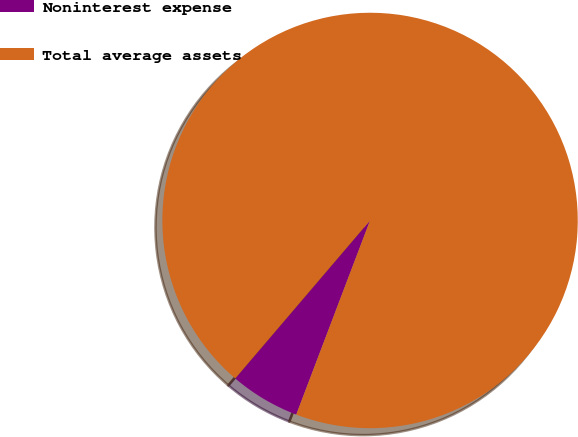Convert chart to OTSL. <chart><loc_0><loc_0><loc_500><loc_500><pie_chart><fcel>Noninterest expense<fcel>Total average assets<nl><fcel>5.46%<fcel>94.54%<nl></chart> 